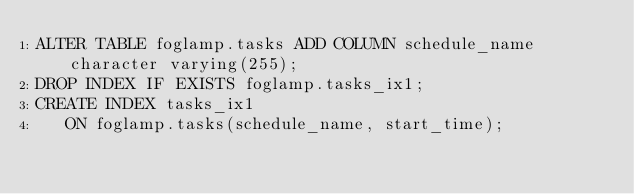Convert code to text. <code><loc_0><loc_0><loc_500><loc_500><_SQL_>ALTER TABLE foglamp.tasks ADD COLUMN schedule_name character varying(255);
DROP INDEX IF EXISTS foglamp.tasks_ix1;
CREATE INDEX tasks_ix1
   ON foglamp.tasks(schedule_name, start_time);</code> 